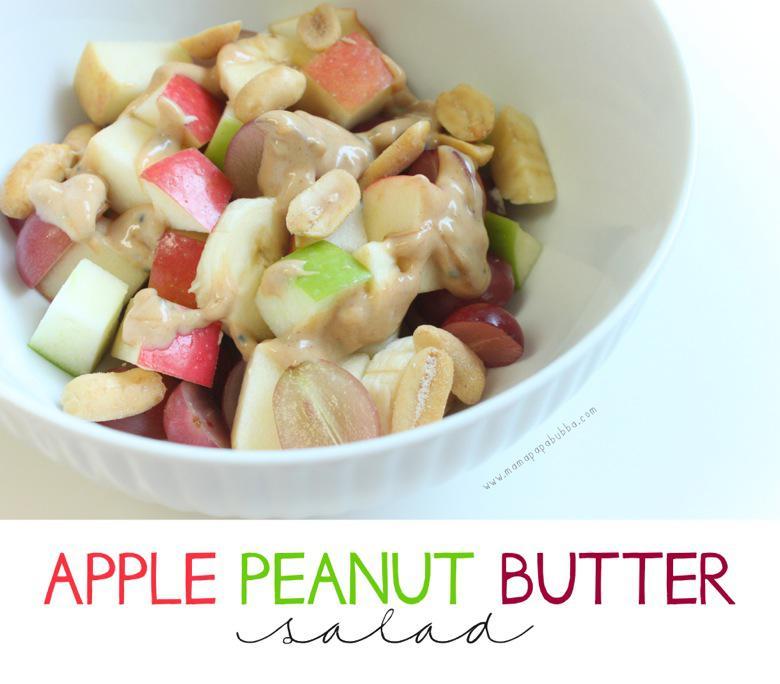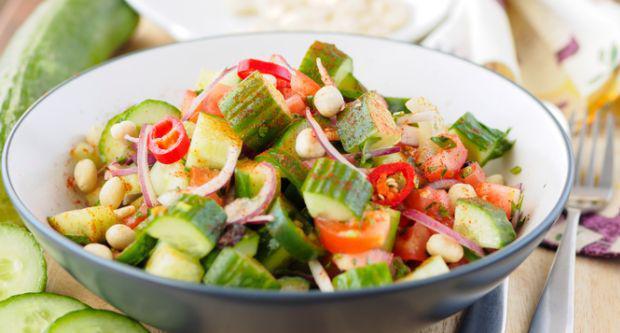The first image is the image on the left, the second image is the image on the right. For the images displayed, is the sentence "In at least one image there is a salad on a plate with apple and sliced red onions." factually correct? Answer yes or no. No. The first image is the image on the left, the second image is the image on the right. Analyze the images presented: Is the assertion "One image shows ingredients sitting on a bed of green lettuce leaves on a dish." valid? Answer yes or no. No. 